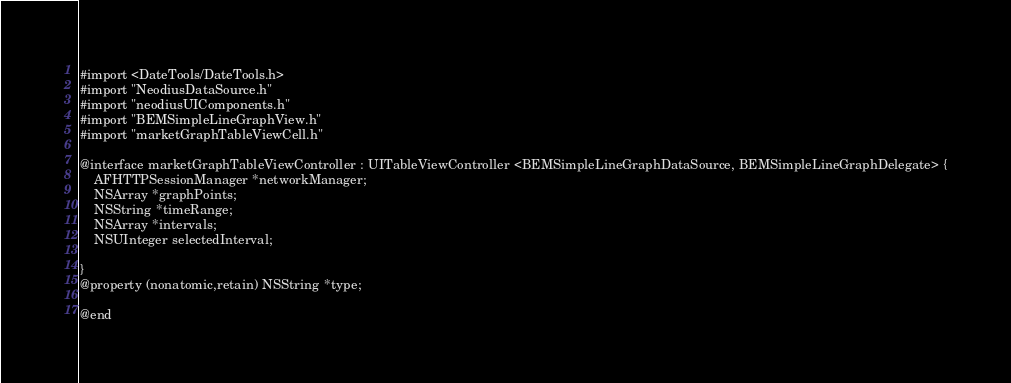<code> <loc_0><loc_0><loc_500><loc_500><_C_>#import <DateTools/DateTools.h>
#import "NeodiusDataSource.h"
#import "neodiusUIComponents.h"
#import "BEMSimpleLineGraphView.h"
#import "marketGraphTableViewCell.h"

@interface marketGraphTableViewController : UITableViewController <BEMSimpleLineGraphDataSource, BEMSimpleLineGraphDelegate> {
    AFHTTPSessionManager *networkManager;
    NSArray *graphPoints;
    NSString *timeRange;
    NSArray *intervals;
    NSUInteger selectedInterval;

}
@property (nonatomic,retain) NSString *type;

@end
</code> 